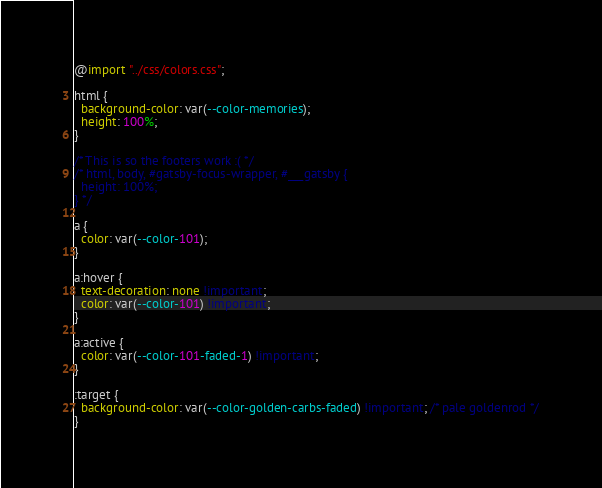<code> <loc_0><loc_0><loc_500><loc_500><_CSS_>@import "../css/colors.css";

html {
  background-color: var(--color-memories);
  height: 100%;
}

/* This is so the footers work :( */
/* html, body, #gatsby-focus-wrapper, #___gatsby {
  height: 100%;
} */

a {
  color: var(--color-101);
}

a:hover {
  text-decoration: none !important;
  color: var(--color-101) !important;
}

a:active {
  color: var(--color-101-faded-1) !important;
}

:target {
  background-color: var(--color-golden-carbs-faded) !important; /* pale goldenrod */
}</code> 